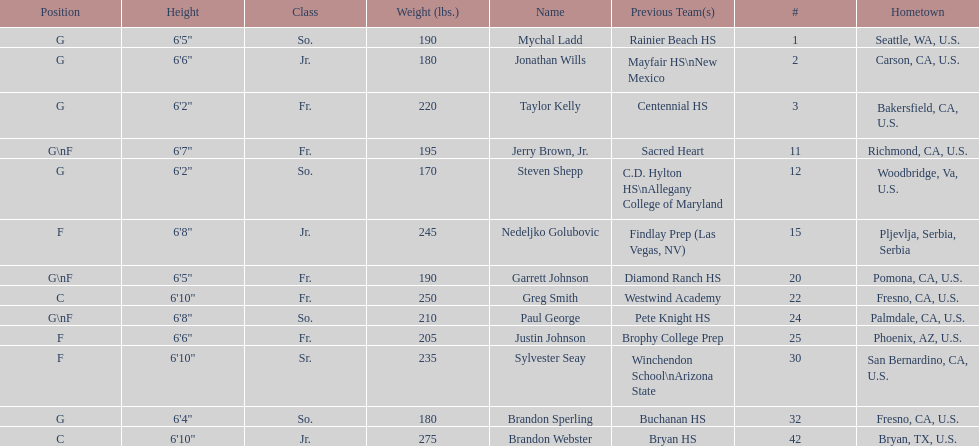Which player is taller, paul george or greg smith? Greg Smith. 